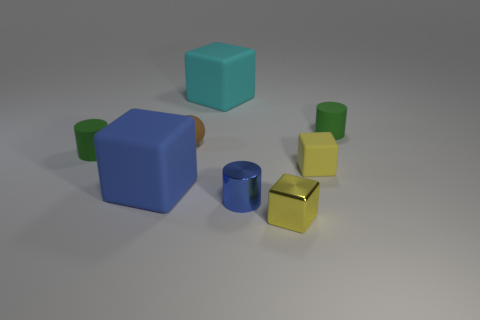Add 1 tiny blue objects. How many objects exist? 9 Subtract all cylinders. How many objects are left? 5 Add 2 big gray matte things. How many big gray matte things exist? 2 Subtract 0 red cylinders. How many objects are left? 8 Subtract all tiny green cylinders. Subtract all blue matte things. How many objects are left? 5 Add 2 large blue matte blocks. How many large blue matte blocks are left? 3 